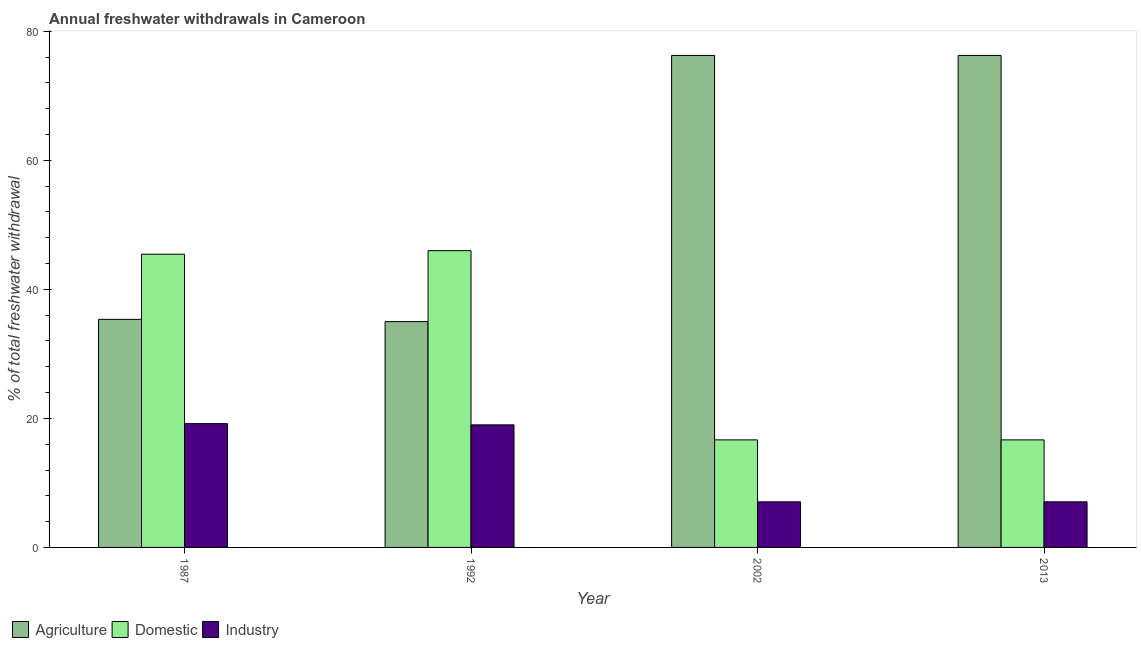How many groups of bars are there?
Your answer should be very brief. 4. Are the number of bars per tick equal to the number of legend labels?
Keep it short and to the point. Yes. How many bars are there on the 1st tick from the right?
Provide a succinct answer. 3. In how many cases, is the number of bars for a given year not equal to the number of legend labels?
Your answer should be very brief. 0. What is the percentage of freshwater withdrawal for agriculture in 2013?
Give a very brief answer. 76.26. Across all years, what is the minimum percentage of freshwater withdrawal for domestic purposes?
Provide a succinct answer. 16.67. What is the total percentage of freshwater withdrawal for agriculture in the graph?
Ensure brevity in your answer.  222.87. What is the difference between the percentage of freshwater withdrawal for industry in 1992 and that in 2002?
Give a very brief answer. 11.93. What is the difference between the percentage of freshwater withdrawal for domestic purposes in 1992 and the percentage of freshwater withdrawal for industry in 2002?
Provide a succinct answer. 29.33. What is the average percentage of freshwater withdrawal for domestic purposes per year?
Your response must be concise. 31.2. In how many years, is the percentage of freshwater withdrawal for domestic purposes greater than 36 %?
Keep it short and to the point. 2. What is the ratio of the percentage of freshwater withdrawal for industry in 2002 to that in 2013?
Your answer should be compact. 1. Is the percentage of freshwater withdrawal for domestic purposes in 1987 less than that in 1992?
Provide a short and direct response. Yes. Is the difference between the percentage of freshwater withdrawal for industry in 1987 and 2013 greater than the difference between the percentage of freshwater withdrawal for domestic purposes in 1987 and 2013?
Make the answer very short. No. What is the difference between the highest and the second highest percentage of freshwater withdrawal for industry?
Your answer should be very brief. 0.19. What is the difference between the highest and the lowest percentage of freshwater withdrawal for agriculture?
Make the answer very short. 41.26. What does the 1st bar from the left in 1987 represents?
Keep it short and to the point. Agriculture. What does the 1st bar from the right in 1992 represents?
Your answer should be very brief. Industry. Is it the case that in every year, the sum of the percentage of freshwater withdrawal for agriculture and percentage of freshwater withdrawal for domestic purposes is greater than the percentage of freshwater withdrawal for industry?
Your response must be concise. Yes. Are all the bars in the graph horizontal?
Your answer should be compact. No. What is the difference between two consecutive major ticks on the Y-axis?
Give a very brief answer. 20. Are the values on the major ticks of Y-axis written in scientific E-notation?
Provide a short and direct response. No. Does the graph contain any zero values?
Offer a very short reply. No. How many legend labels are there?
Keep it short and to the point. 3. How are the legend labels stacked?
Your answer should be very brief. Horizontal. What is the title of the graph?
Offer a terse response. Annual freshwater withdrawals in Cameroon. What is the label or title of the X-axis?
Your answer should be very brief. Year. What is the label or title of the Y-axis?
Ensure brevity in your answer.  % of total freshwater withdrawal. What is the % of total freshwater withdrawal of Agriculture in 1987?
Your answer should be very brief. 35.35. What is the % of total freshwater withdrawal in Domestic in 1987?
Your response must be concise. 45.45. What is the % of total freshwater withdrawal in Industry in 1987?
Your response must be concise. 19.19. What is the % of total freshwater withdrawal of Domestic in 1992?
Keep it short and to the point. 46. What is the % of total freshwater withdrawal of Agriculture in 2002?
Provide a short and direct response. 76.26. What is the % of total freshwater withdrawal of Domestic in 2002?
Ensure brevity in your answer.  16.67. What is the % of total freshwater withdrawal in Industry in 2002?
Your answer should be very brief. 7.07. What is the % of total freshwater withdrawal in Agriculture in 2013?
Offer a terse response. 76.26. What is the % of total freshwater withdrawal of Domestic in 2013?
Offer a very short reply. 16.67. What is the % of total freshwater withdrawal in Industry in 2013?
Make the answer very short. 7.07. Across all years, what is the maximum % of total freshwater withdrawal in Agriculture?
Your answer should be compact. 76.26. Across all years, what is the maximum % of total freshwater withdrawal in Domestic?
Offer a terse response. 46. Across all years, what is the maximum % of total freshwater withdrawal of Industry?
Make the answer very short. 19.19. Across all years, what is the minimum % of total freshwater withdrawal of Agriculture?
Provide a short and direct response. 35. Across all years, what is the minimum % of total freshwater withdrawal in Domestic?
Give a very brief answer. 16.67. Across all years, what is the minimum % of total freshwater withdrawal of Industry?
Your answer should be compact. 7.07. What is the total % of total freshwater withdrawal in Agriculture in the graph?
Give a very brief answer. 222.87. What is the total % of total freshwater withdrawal of Domestic in the graph?
Keep it short and to the point. 124.79. What is the total % of total freshwater withdrawal in Industry in the graph?
Your answer should be compact. 52.32. What is the difference between the % of total freshwater withdrawal of Domestic in 1987 and that in 1992?
Offer a terse response. -0.55. What is the difference between the % of total freshwater withdrawal in Industry in 1987 and that in 1992?
Make the answer very short. 0.19. What is the difference between the % of total freshwater withdrawal in Agriculture in 1987 and that in 2002?
Ensure brevity in your answer.  -40.91. What is the difference between the % of total freshwater withdrawal of Domestic in 1987 and that in 2002?
Your answer should be compact. 28.78. What is the difference between the % of total freshwater withdrawal of Industry in 1987 and that in 2002?
Give a very brief answer. 12.12. What is the difference between the % of total freshwater withdrawal in Agriculture in 1987 and that in 2013?
Your answer should be very brief. -40.91. What is the difference between the % of total freshwater withdrawal of Domestic in 1987 and that in 2013?
Provide a succinct answer. 28.78. What is the difference between the % of total freshwater withdrawal in Industry in 1987 and that in 2013?
Provide a short and direct response. 12.12. What is the difference between the % of total freshwater withdrawal in Agriculture in 1992 and that in 2002?
Your answer should be very brief. -41.26. What is the difference between the % of total freshwater withdrawal in Domestic in 1992 and that in 2002?
Keep it short and to the point. 29.33. What is the difference between the % of total freshwater withdrawal in Industry in 1992 and that in 2002?
Offer a terse response. 11.93. What is the difference between the % of total freshwater withdrawal in Agriculture in 1992 and that in 2013?
Offer a terse response. -41.26. What is the difference between the % of total freshwater withdrawal in Domestic in 1992 and that in 2013?
Make the answer very short. 29.33. What is the difference between the % of total freshwater withdrawal of Industry in 1992 and that in 2013?
Your answer should be very brief. 11.93. What is the difference between the % of total freshwater withdrawal of Domestic in 2002 and that in 2013?
Keep it short and to the point. 0. What is the difference between the % of total freshwater withdrawal of Agriculture in 1987 and the % of total freshwater withdrawal of Domestic in 1992?
Your answer should be very brief. -10.65. What is the difference between the % of total freshwater withdrawal of Agriculture in 1987 and the % of total freshwater withdrawal of Industry in 1992?
Provide a short and direct response. 16.35. What is the difference between the % of total freshwater withdrawal of Domestic in 1987 and the % of total freshwater withdrawal of Industry in 1992?
Offer a terse response. 26.45. What is the difference between the % of total freshwater withdrawal in Agriculture in 1987 and the % of total freshwater withdrawal in Domestic in 2002?
Make the answer very short. 18.68. What is the difference between the % of total freshwater withdrawal in Agriculture in 1987 and the % of total freshwater withdrawal in Industry in 2002?
Offer a terse response. 28.28. What is the difference between the % of total freshwater withdrawal in Domestic in 1987 and the % of total freshwater withdrawal in Industry in 2002?
Your answer should be compact. 38.38. What is the difference between the % of total freshwater withdrawal of Agriculture in 1987 and the % of total freshwater withdrawal of Domestic in 2013?
Offer a very short reply. 18.68. What is the difference between the % of total freshwater withdrawal of Agriculture in 1987 and the % of total freshwater withdrawal of Industry in 2013?
Give a very brief answer. 28.28. What is the difference between the % of total freshwater withdrawal in Domestic in 1987 and the % of total freshwater withdrawal in Industry in 2013?
Offer a terse response. 38.38. What is the difference between the % of total freshwater withdrawal in Agriculture in 1992 and the % of total freshwater withdrawal in Domestic in 2002?
Your answer should be compact. 18.33. What is the difference between the % of total freshwater withdrawal of Agriculture in 1992 and the % of total freshwater withdrawal of Industry in 2002?
Give a very brief answer. 27.93. What is the difference between the % of total freshwater withdrawal in Domestic in 1992 and the % of total freshwater withdrawal in Industry in 2002?
Your response must be concise. 38.93. What is the difference between the % of total freshwater withdrawal in Agriculture in 1992 and the % of total freshwater withdrawal in Domestic in 2013?
Your answer should be compact. 18.33. What is the difference between the % of total freshwater withdrawal of Agriculture in 1992 and the % of total freshwater withdrawal of Industry in 2013?
Provide a short and direct response. 27.93. What is the difference between the % of total freshwater withdrawal of Domestic in 1992 and the % of total freshwater withdrawal of Industry in 2013?
Offer a very short reply. 38.93. What is the difference between the % of total freshwater withdrawal of Agriculture in 2002 and the % of total freshwater withdrawal of Domestic in 2013?
Keep it short and to the point. 59.59. What is the difference between the % of total freshwater withdrawal in Agriculture in 2002 and the % of total freshwater withdrawal in Industry in 2013?
Provide a short and direct response. 69.19. What is the difference between the % of total freshwater withdrawal of Domestic in 2002 and the % of total freshwater withdrawal of Industry in 2013?
Your response must be concise. 9.6. What is the average % of total freshwater withdrawal of Agriculture per year?
Ensure brevity in your answer.  55.72. What is the average % of total freshwater withdrawal of Domestic per year?
Offer a terse response. 31.2. What is the average % of total freshwater withdrawal in Industry per year?
Provide a succinct answer. 13.08. In the year 1987, what is the difference between the % of total freshwater withdrawal of Agriculture and % of total freshwater withdrawal of Industry?
Give a very brief answer. 16.16. In the year 1987, what is the difference between the % of total freshwater withdrawal of Domestic and % of total freshwater withdrawal of Industry?
Keep it short and to the point. 26.26. In the year 1992, what is the difference between the % of total freshwater withdrawal in Agriculture and % of total freshwater withdrawal in Domestic?
Offer a terse response. -11. In the year 1992, what is the difference between the % of total freshwater withdrawal in Agriculture and % of total freshwater withdrawal in Industry?
Give a very brief answer. 16. In the year 1992, what is the difference between the % of total freshwater withdrawal in Domestic and % of total freshwater withdrawal in Industry?
Your response must be concise. 27. In the year 2002, what is the difference between the % of total freshwater withdrawal in Agriculture and % of total freshwater withdrawal in Domestic?
Your response must be concise. 59.59. In the year 2002, what is the difference between the % of total freshwater withdrawal in Agriculture and % of total freshwater withdrawal in Industry?
Ensure brevity in your answer.  69.19. In the year 2002, what is the difference between the % of total freshwater withdrawal in Domestic and % of total freshwater withdrawal in Industry?
Ensure brevity in your answer.  9.6. In the year 2013, what is the difference between the % of total freshwater withdrawal in Agriculture and % of total freshwater withdrawal in Domestic?
Make the answer very short. 59.59. In the year 2013, what is the difference between the % of total freshwater withdrawal in Agriculture and % of total freshwater withdrawal in Industry?
Your answer should be compact. 69.19. In the year 2013, what is the difference between the % of total freshwater withdrawal in Domestic and % of total freshwater withdrawal in Industry?
Your response must be concise. 9.6. What is the ratio of the % of total freshwater withdrawal in Agriculture in 1987 to that in 1992?
Ensure brevity in your answer.  1.01. What is the ratio of the % of total freshwater withdrawal of Agriculture in 1987 to that in 2002?
Make the answer very short. 0.46. What is the ratio of the % of total freshwater withdrawal of Domestic in 1987 to that in 2002?
Provide a short and direct response. 2.73. What is the ratio of the % of total freshwater withdrawal in Industry in 1987 to that in 2002?
Your answer should be very brief. 2.72. What is the ratio of the % of total freshwater withdrawal of Agriculture in 1987 to that in 2013?
Your answer should be compact. 0.46. What is the ratio of the % of total freshwater withdrawal of Domestic in 1987 to that in 2013?
Ensure brevity in your answer.  2.73. What is the ratio of the % of total freshwater withdrawal of Industry in 1987 to that in 2013?
Give a very brief answer. 2.72. What is the ratio of the % of total freshwater withdrawal of Agriculture in 1992 to that in 2002?
Provide a succinct answer. 0.46. What is the ratio of the % of total freshwater withdrawal in Domestic in 1992 to that in 2002?
Your answer should be compact. 2.76. What is the ratio of the % of total freshwater withdrawal of Industry in 1992 to that in 2002?
Your response must be concise. 2.69. What is the ratio of the % of total freshwater withdrawal of Agriculture in 1992 to that in 2013?
Give a very brief answer. 0.46. What is the ratio of the % of total freshwater withdrawal in Domestic in 1992 to that in 2013?
Offer a terse response. 2.76. What is the ratio of the % of total freshwater withdrawal of Industry in 1992 to that in 2013?
Provide a succinct answer. 2.69. What is the ratio of the % of total freshwater withdrawal in Agriculture in 2002 to that in 2013?
Your response must be concise. 1. What is the ratio of the % of total freshwater withdrawal of Industry in 2002 to that in 2013?
Your response must be concise. 1. What is the difference between the highest and the second highest % of total freshwater withdrawal in Domestic?
Ensure brevity in your answer.  0.55. What is the difference between the highest and the second highest % of total freshwater withdrawal of Industry?
Give a very brief answer. 0.19. What is the difference between the highest and the lowest % of total freshwater withdrawal of Agriculture?
Offer a terse response. 41.26. What is the difference between the highest and the lowest % of total freshwater withdrawal of Domestic?
Keep it short and to the point. 29.33. What is the difference between the highest and the lowest % of total freshwater withdrawal of Industry?
Offer a very short reply. 12.12. 